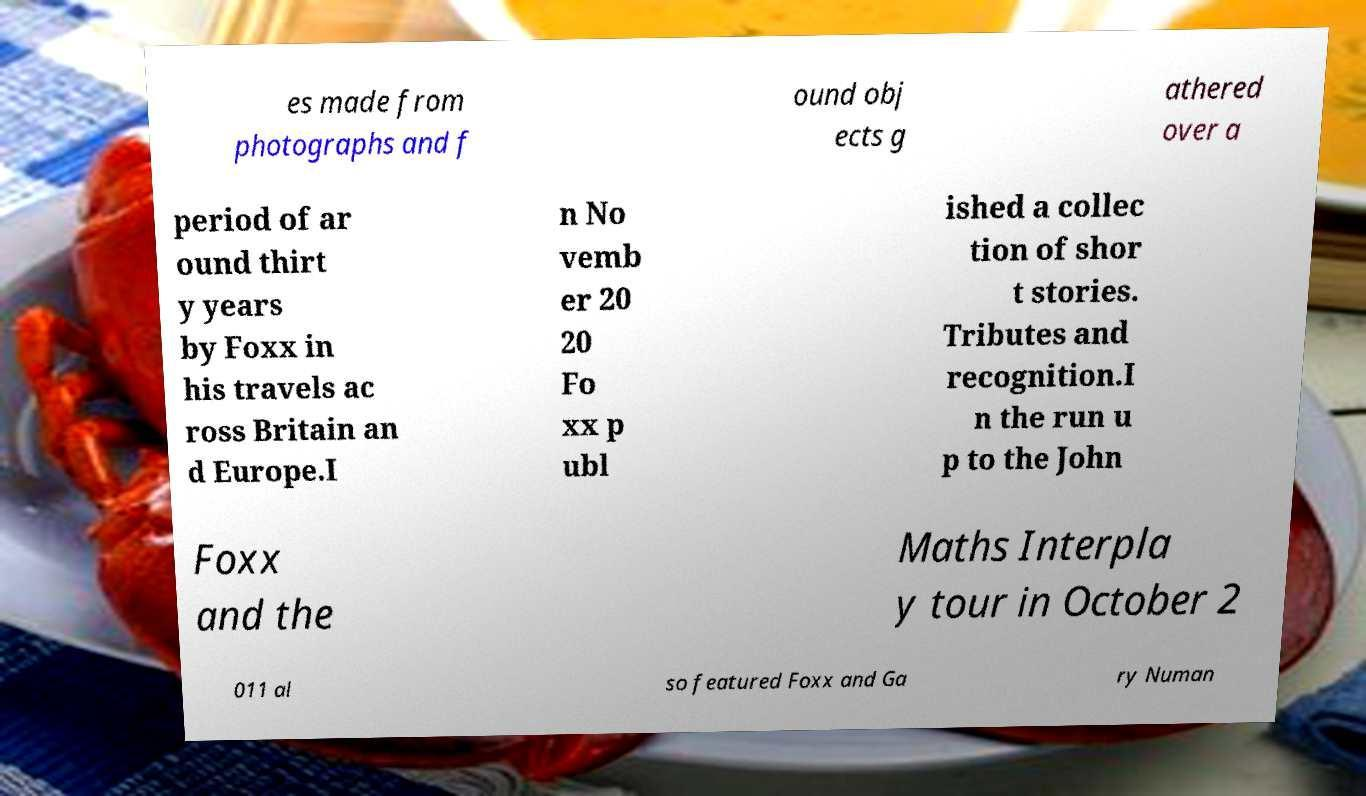Can you read and provide the text displayed in the image?This photo seems to have some interesting text. Can you extract and type it out for me? es made from photographs and f ound obj ects g athered over a period of ar ound thirt y years by Foxx in his travels ac ross Britain an d Europe.I n No vemb er 20 20 Fo xx p ubl ished a collec tion of shor t stories. Tributes and recognition.I n the run u p to the John Foxx and the Maths Interpla y tour in October 2 011 al so featured Foxx and Ga ry Numan 